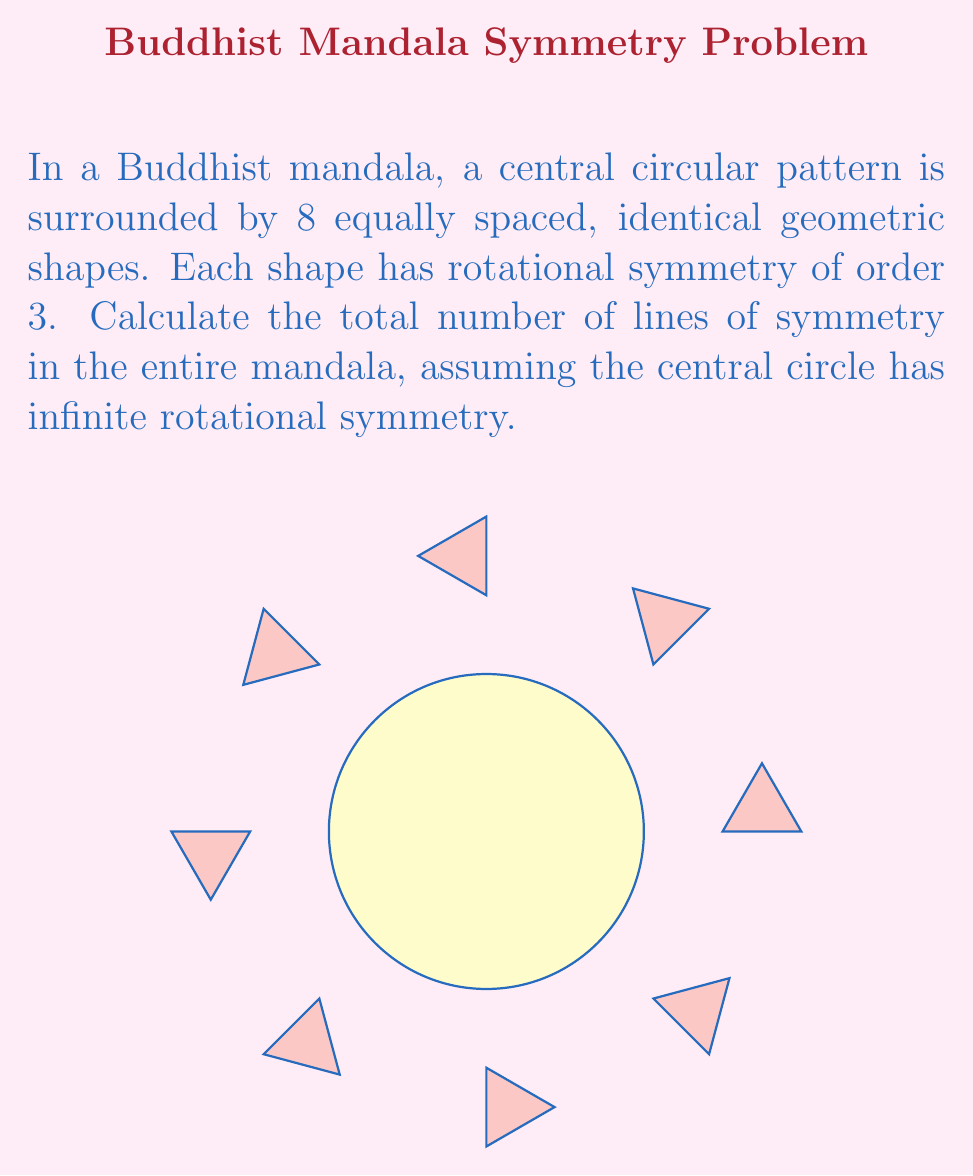Help me with this question. To calculate the total number of lines of symmetry in the mandala, we need to consider both rotational and reflectional symmetry:

1. Central circle:
   - The central circle has infinite rotational symmetry, which contributes to the overall symmetry.
   - It also has infinite lines of reflection symmetry passing through its center.

2. Surrounding shapes:
   - There are 8 identical shapes arranged in a circular pattern.
   - Each shape has rotational symmetry of order 3, meaning it can be rotated by $\frac{360°}{3} = 120°$ and appear the same.

3. Rotational symmetry of the entire mandala:
   - The mandala has 8-fold rotational symmetry due to the arrangement of the 8 shapes.
   - This means it can be rotated by $\frac{360°}{8} = 45°$ and appear the same.

4. Reflectional symmetry:
   - There are 8 lines of reflection symmetry passing through the center of the mandala:
     a. 4 lines passing through opposite shapes
     b. 4 lines passing between adjacent shapes

5. Total lines of symmetry:
   - The number of lines of symmetry is equal to the number of reflection lines.
   - In this case, there are 8 lines of symmetry.

The rotational symmetry of the individual shapes and the central circle contribute to the overall symmetry of the mandala but do not add to the count of lines of symmetry.
Answer: 8 